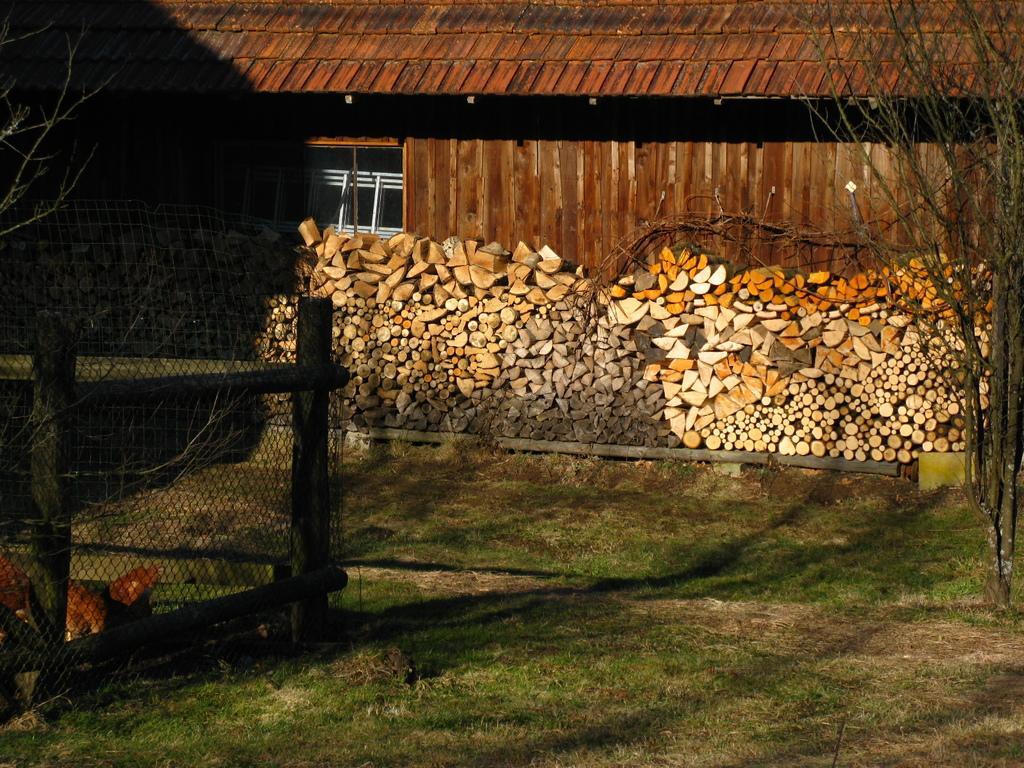In one or two sentences, can you explain what this image depicts? In this picture there is a building and there are trees and there are logs. On the left side of the image there is an animal behind the fence. At the bottom there is grass and ground. 